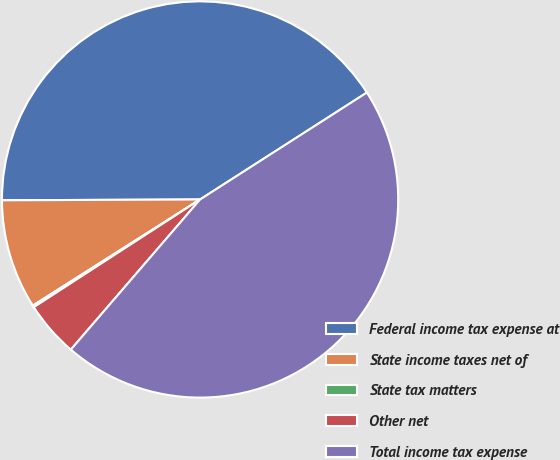Convert chart. <chart><loc_0><loc_0><loc_500><loc_500><pie_chart><fcel>Federal income tax expense at<fcel>State income taxes net of<fcel>State tax matters<fcel>Other net<fcel>Total income tax expense<nl><fcel>40.99%<fcel>8.93%<fcel>0.15%<fcel>4.54%<fcel>45.38%<nl></chart> 